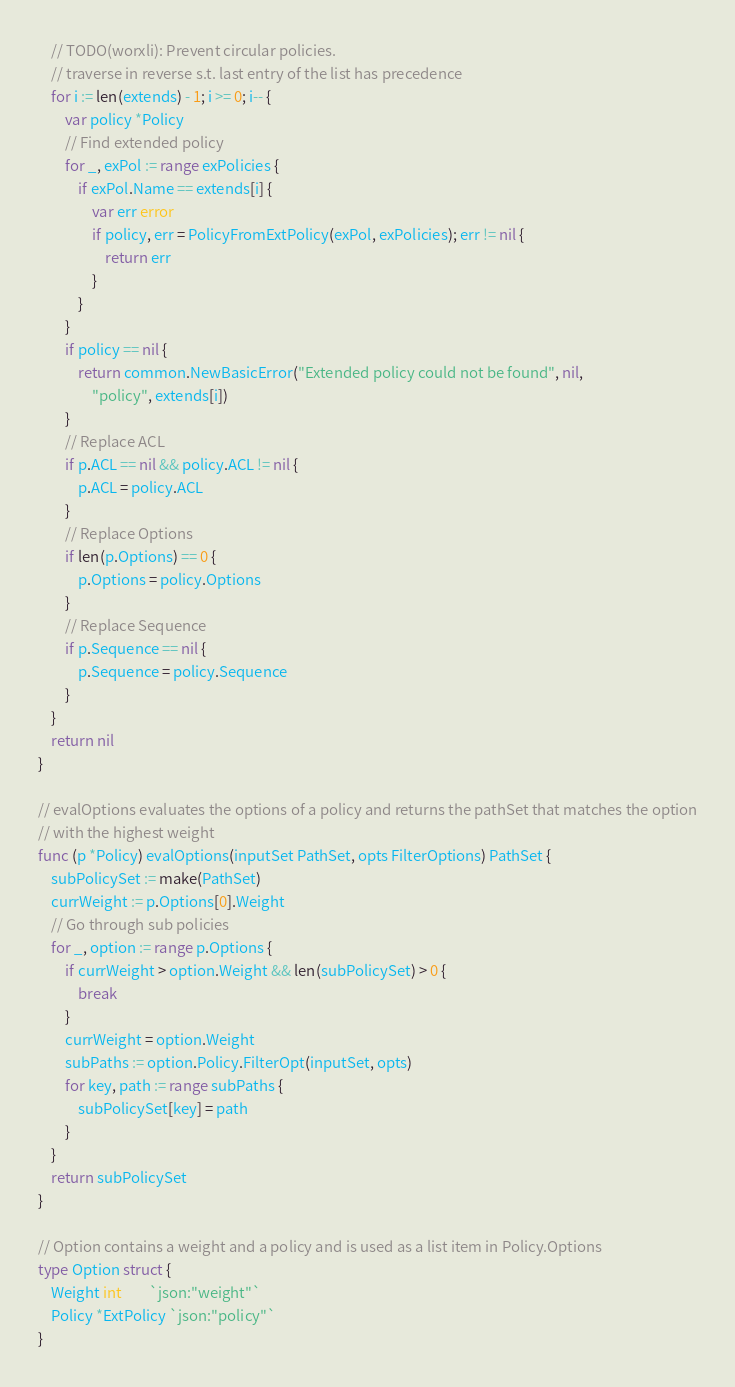Convert code to text. <code><loc_0><loc_0><loc_500><loc_500><_Go_>	// TODO(worxli): Prevent circular policies.
	// traverse in reverse s.t. last entry of the list has precedence
	for i := len(extends) - 1; i >= 0; i-- {
		var policy *Policy
		// Find extended policy
		for _, exPol := range exPolicies {
			if exPol.Name == extends[i] {
				var err error
				if policy, err = PolicyFromExtPolicy(exPol, exPolicies); err != nil {
					return err
				}
			}
		}
		if policy == nil {
			return common.NewBasicError("Extended policy could not be found", nil,
				"policy", extends[i])
		}
		// Replace ACL
		if p.ACL == nil && policy.ACL != nil {
			p.ACL = policy.ACL
		}
		// Replace Options
		if len(p.Options) == 0 {
			p.Options = policy.Options
		}
		// Replace Sequence
		if p.Sequence == nil {
			p.Sequence = policy.Sequence
		}
	}
	return nil
}

// evalOptions evaluates the options of a policy and returns the pathSet that matches the option
// with the highest weight
func (p *Policy) evalOptions(inputSet PathSet, opts FilterOptions) PathSet {
	subPolicySet := make(PathSet)
	currWeight := p.Options[0].Weight
	// Go through sub policies
	for _, option := range p.Options {
		if currWeight > option.Weight && len(subPolicySet) > 0 {
			break
		}
		currWeight = option.Weight
		subPaths := option.Policy.FilterOpt(inputSet, opts)
		for key, path := range subPaths {
			subPolicySet[key] = path
		}
	}
	return subPolicySet
}

// Option contains a weight and a policy and is used as a list item in Policy.Options
type Option struct {
	Weight int        `json:"weight"`
	Policy *ExtPolicy `json:"policy"`
}
</code> 